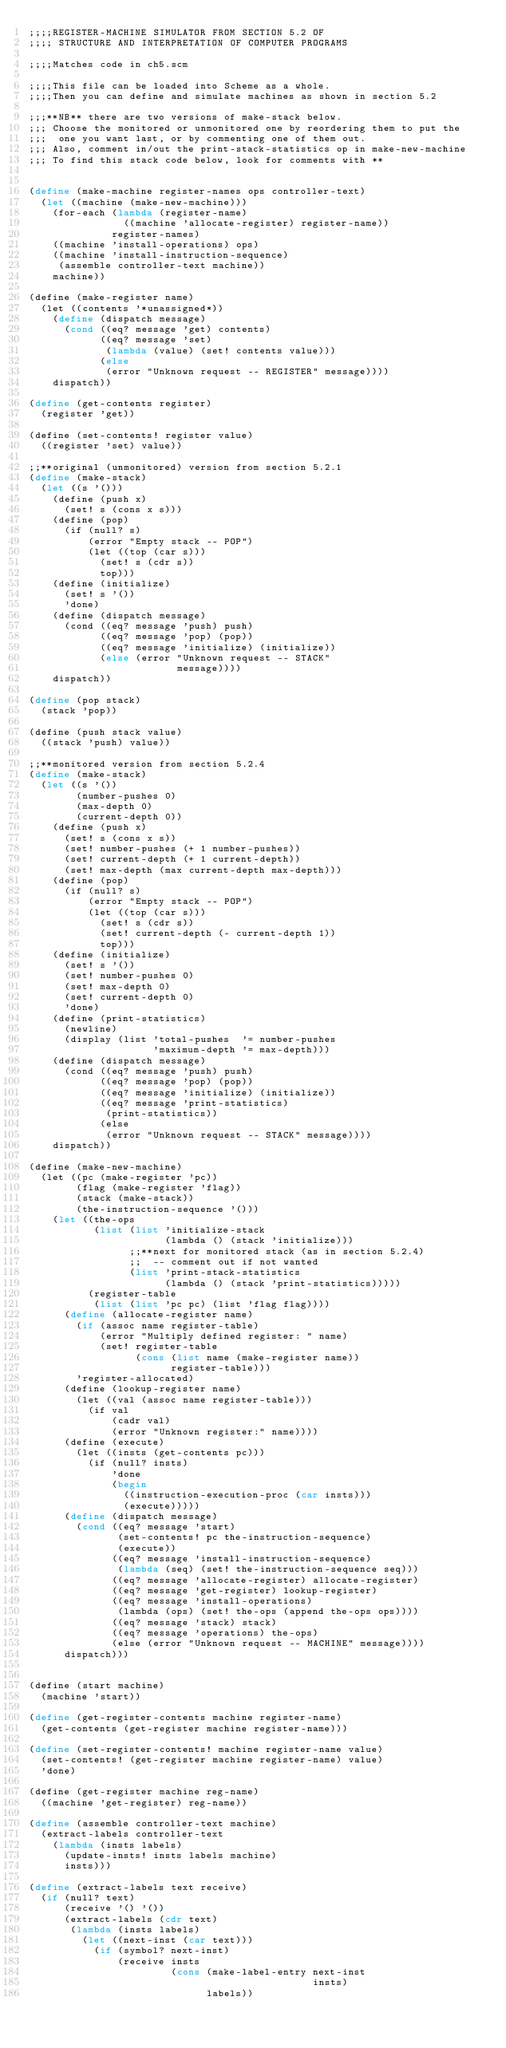Convert code to text. <code><loc_0><loc_0><loc_500><loc_500><_Scheme_>;;;;REGISTER-MACHINE SIMULATOR FROM SECTION 5.2 OF
;;;; STRUCTURE AND INTERPRETATION OF COMPUTER PROGRAMS

;;;;Matches code in ch5.scm

;;;;This file can be loaded into Scheme as a whole.
;;;;Then you can define and simulate machines as shown in section 5.2

;;;**NB** there are two versions of make-stack below.
;;; Choose the monitored or unmonitored one by reordering them to put the
;;;  one you want last, or by commenting one of them out.
;;; Also, comment in/out the print-stack-statistics op in make-new-machine
;;; To find this stack code below, look for comments with **


(define (make-machine register-names ops controller-text)
  (let ((machine (make-new-machine)))
    (for-each (lambda (register-name)
                ((machine 'allocate-register) register-name))
              register-names)
    ((machine 'install-operations) ops)    
    ((machine 'install-instruction-sequence)
     (assemble controller-text machine))
    machine))

(define (make-register name)
  (let ((contents '*unassigned*))
    (define (dispatch message)
      (cond ((eq? message 'get) contents)
            ((eq? message 'set)
             (lambda (value) (set! contents value)))
            (else
             (error "Unknown request -- REGISTER" message))))
    dispatch))

(define (get-contents register)
  (register 'get))

(define (set-contents! register value)
  ((register 'set) value))

;;**original (unmonitored) version from section 5.2.1
(define (make-stack)
  (let ((s '()))
    (define (push x)
      (set! s (cons x s)))
    (define (pop)
      (if (null? s)
          (error "Empty stack -- POP")
          (let ((top (car s)))
            (set! s (cdr s))
            top)))
    (define (initialize)
      (set! s '())
      'done)
    (define (dispatch message)
      (cond ((eq? message 'push) push)
            ((eq? message 'pop) (pop))
            ((eq? message 'initialize) (initialize))
            (else (error "Unknown request -- STACK"
                         message))))
    dispatch))

(define (pop stack)
  (stack 'pop))

(define (push stack value)
  ((stack 'push) value))

;;**monitored version from section 5.2.4
(define (make-stack)
  (let ((s '())
        (number-pushes 0)
        (max-depth 0)
        (current-depth 0))
    (define (push x)
      (set! s (cons x s))
      (set! number-pushes (+ 1 number-pushes))
      (set! current-depth (+ 1 current-depth))
      (set! max-depth (max current-depth max-depth)))
    (define (pop)
      (if (null? s)
          (error "Empty stack -- POP")
          (let ((top (car s)))
            (set! s (cdr s))
            (set! current-depth (- current-depth 1))
            top)))    
    (define (initialize)
      (set! s '())
      (set! number-pushes 0)
      (set! max-depth 0)
      (set! current-depth 0)
      'done)
    (define (print-statistics)
      (newline)
      (display (list 'total-pushes  '= number-pushes
                     'maximum-depth '= max-depth)))
    (define (dispatch message)
      (cond ((eq? message 'push) push)
            ((eq? message 'pop) (pop))
            ((eq? message 'initialize) (initialize))
            ((eq? message 'print-statistics)
             (print-statistics))
            (else
             (error "Unknown request -- STACK" message))))
    dispatch))

(define (make-new-machine)
  (let ((pc (make-register 'pc))
        (flag (make-register 'flag))
        (stack (make-stack))
        (the-instruction-sequence '()))
    (let ((the-ops
           (list (list 'initialize-stack
                       (lambda () (stack 'initialize)))
                 ;;**next for monitored stack (as in section 5.2.4)
                 ;;  -- comment out if not wanted
                 (list 'print-stack-statistics
                       (lambda () (stack 'print-statistics)))))
          (register-table
           (list (list 'pc pc) (list 'flag flag))))
      (define (allocate-register name)
        (if (assoc name register-table)
            (error "Multiply defined register: " name)
            (set! register-table
                  (cons (list name (make-register name))
                        register-table)))
        'register-allocated)
      (define (lookup-register name)
        (let ((val (assoc name register-table)))
          (if val
              (cadr val)
              (error "Unknown register:" name))))
      (define (execute)
        (let ((insts (get-contents pc)))
          (if (null? insts)
              'done
              (begin
                ((instruction-execution-proc (car insts)))
                (execute)))))
      (define (dispatch message)
        (cond ((eq? message 'start)
               (set-contents! pc the-instruction-sequence)
               (execute))
              ((eq? message 'install-instruction-sequence)
               (lambda (seq) (set! the-instruction-sequence seq)))
              ((eq? message 'allocate-register) allocate-register)
              ((eq? message 'get-register) lookup-register)
              ((eq? message 'install-operations)
               (lambda (ops) (set! the-ops (append the-ops ops))))
              ((eq? message 'stack) stack)
              ((eq? message 'operations) the-ops)
              (else (error "Unknown request -- MACHINE" message))))
      dispatch)))


(define (start machine)
  (machine 'start))

(define (get-register-contents machine register-name)
  (get-contents (get-register machine register-name)))

(define (set-register-contents! machine register-name value)
  (set-contents! (get-register machine register-name) value)
  'done)

(define (get-register machine reg-name)
  ((machine 'get-register) reg-name))

(define (assemble controller-text machine)
  (extract-labels controller-text
    (lambda (insts labels)
      (update-insts! insts labels machine)
      insts)))

(define (extract-labels text receive)
  (if (null? text)
      (receive '() '())
      (extract-labels (cdr text)
       (lambda (insts labels)
         (let ((next-inst (car text)))
           (if (symbol? next-inst)
               (receive insts
                        (cons (make-label-entry next-inst
                                                insts)
                              labels))</code> 